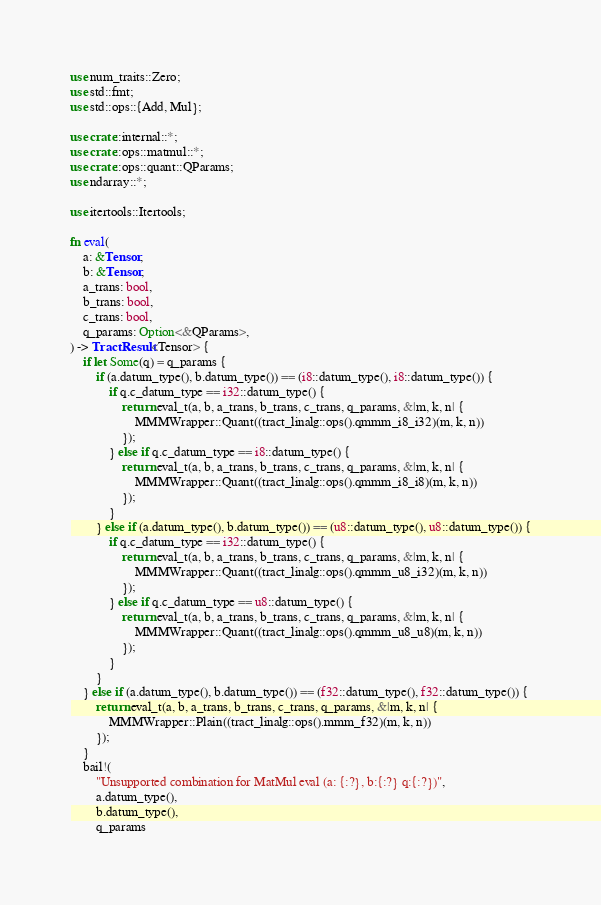<code> <loc_0><loc_0><loc_500><loc_500><_Rust_>use num_traits::Zero;
use std::fmt;
use std::ops::{Add, Mul};

use crate::internal::*;
use crate::ops::matmul::*;
use crate::ops::quant::QParams;
use ndarray::*;

use itertools::Itertools;

fn eval(
    a: &Tensor,
    b: &Tensor,
    a_trans: bool,
    b_trans: bool,
    c_trans: bool,
    q_params: Option<&QParams>,
) -> TractResult<Tensor> {
    if let Some(q) = q_params {
        if (a.datum_type(), b.datum_type()) == (i8::datum_type(), i8::datum_type()) {
            if q.c_datum_type == i32::datum_type() {
                return eval_t(a, b, a_trans, b_trans, c_trans, q_params, &|m, k, n| {
                    MMMWrapper::Quant((tract_linalg::ops().qmmm_i8_i32)(m, k, n))
                });
            } else if q.c_datum_type == i8::datum_type() {
                return eval_t(a, b, a_trans, b_trans, c_trans, q_params, &|m, k, n| {
                    MMMWrapper::Quant((tract_linalg::ops().qmmm_i8_i8)(m, k, n))
                });
            }
        } else if (a.datum_type(), b.datum_type()) == (u8::datum_type(), u8::datum_type()) {
            if q.c_datum_type == i32::datum_type() {
                return eval_t(a, b, a_trans, b_trans, c_trans, q_params, &|m, k, n| {
                    MMMWrapper::Quant((tract_linalg::ops().qmmm_u8_i32)(m, k, n))
                });
            } else if q.c_datum_type == u8::datum_type() {
                return eval_t(a, b, a_trans, b_trans, c_trans, q_params, &|m, k, n| {
                    MMMWrapper::Quant((tract_linalg::ops().qmmm_u8_u8)(m, k, n))
                });
            }
        }
    } else if (a.datum_type(), b.datum_type()) == (f32::datum_type(), f32::datum_type()) {
        return eval_t(a, b, a_trans, b_trans, c_trans, q_params, &|m, k, n| {
            MMMWrapper::Plain((tract_linalg::ops().mmm_f32)(m, k, n))
        });
    }
    bail!(
        "Unsupported combination for MatMul eval (a: {:?}, b:{:?} q:{:?})",
        a.datum_type(),
        b.datum_type(),
        q_params</code> 